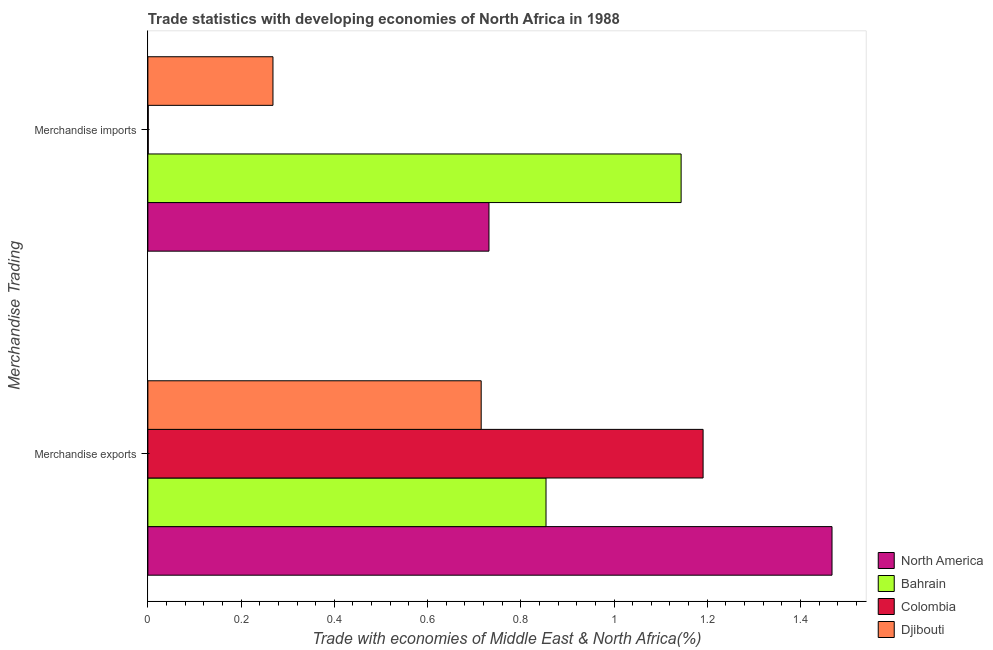How many different coloured bars are there?
Make the answer very short. 4. Are the number of bars on each tick of the Y-axis equal?
Your answer should be very brief. Yes. What is the merchandise exports in North America?
Make the answer very short. 1.47. Across all countries, what is the maximum merchandise exports?
Your answer should be very brief. 1.47. Across all countries, what is the minimum merchandise imports?
Your answer should be very brief. 0. In which country was the merchandise exports minimum?
Offer a terse response. Djibouti. What is the total merchandise exports in the graph?
Ensure brevity in your answer.  4.23. What is the difference between the merchandise exports in North America and that in Bahrain?
Provide a short and direct response. 0.61. What is the difference between the merchandise imports in Djibouti and the merchandise exports in Bahrain?
Your answer should be very brief. -0.59. What is the average merchandise imports per country?
Offer a very short reply. 0.54. What is the difference between the merchandise imports and merchandise exports in Bahrain?
Offer a terse response. 0.29. What is the ratio of the merchandise exports in Djibouti to that in Bahrain?
Your answer should be compact. 0.84. What does the 3rd bar from the top in Merchandise exports represents?
Give a very brief answer. Bahrain. What does the 4th bar from the bottom in Merchandise exports represents?
Offer a terse response. Djibouti. How many countries are there in the graph?
Provide a succinct answer. 4. Does the graph contain any zero values?
Your answer should be very brief. No. Does the graph contain grids?
Your answer should be compact. No. How many legend labels are there?
Your answer should be compact. 4. How are the legend labels stacked?
Provide a succinct answer. Vertical. What is the title of the graph?
Ensure brevity in your answer.  Trade statistics with developing economies of North Africa in 1988. Does "Nicaragua" appear as one of the legend labels in the graph?
Offer a very short reply. No. What is the label or title of the X-axis?
Ensure brevity in your answer.  Trade with economies of Middle East & North Africa(%). What is the label or title of the Y-axis?
Your answer should be very brief. Merchandise Trading. What is the Trade with economies of Middle East & North Africa(%) in North America in Merchandise exports?
Your answer should be very brief. 1.47. What is the Trade with economies of Middle East & North Africa(%) in Bahrain in Merchandise exports?
Your answer should be very brief. 0.85. What is the Trade with economies of Middle East & North Africa(%) in Colombia in Merchandise exports?
Provide a succinct answer. 1.19. What is the Trade with economies of Middle East & North Africa(%) of Djibouti in Merchandise exports?
Keep it short and to the point. 0.72. What is the Trade with economies of Middle East & North Africa(%) in North America in Merchandise imports?
Your answer should be very brief. 0.73. What is the Trade with economies of Middle East & North Africa(%) of Bahrain in Merchandise imports?
Give a very brief answer. 1.14. What is the Trade with economies of Middle East & North Africa(%) of Colombia in Merchandise imports?
Your answer should be very brief. 0. What is the Trade with economies of Middle East & North Africa(%) of Djibouti in Merchandise imports?
Offer a very short reply. 0.27. Across all Merchandise Trading, what is the maximum Trade with economies of Middle East & North Africa(%) of North America?
Ensure brevity in your answer.  1.47. Across all Merchandise Trading, what is the maximum Trade with economies of Middle East & North Africa(%) in Bahrain?
Provide a short and direct response. 1.14. Across all Merchandise Trading, what is the maximum Trade with economies of Middle East & North Africa(%) of Colombia?
Make the answer very short. 1.19. Across all Merchandise Trading, what is the maximum Trade with economies of Middle East & North Africa(%) in Djibouti?
Make the answer very short. 0.72. Across all Merchandise Trading, what is the minimum Trade with economies of Middle East & North Africa(%) of North America?
Your answer should be very brief. 0.73. Across all Merchandise Trading, what is the minimum Trade with economies of Middle East & North Africa(%) of Bahrain?
Give a very brief answer. 0.85. Across all Merchandise Trading, what is the minimum Trade with economies of Middle East & North Africa(%) in Colombia?
Offer a very short reply. 0. Across all Merchandise Trading, what is the minimum Trade with economies of Middle East & North Africa(%) of Djibouti?
Your answer should be very brief. 0.27. What is the total Trade with economies of Middle East & North Africa(%) of North America in the graph?
Offer a very short reply. 2.2. What is the total Trade with economies of Middle East & North Africa(%) of Bahrain in the graph?
Your answer should be very brief. 2. What is the total Trade with economies of Middle East & North Africa(%) of Colombia in the graph?
Ensure brevity in your answer.  1.19. What is the total Trade with economies of Middle East & North Africa(%) in Djibouti in the graph?
Your response must be concise. 0.98. What is the difference between the Trade with economies of Middle East & North Africa(%) of North America in Merchandise exports and that in Merchandise imports?
Your answer should be compact. 0.74. What is the difference between the Trade with economies of Middle East & North Africa(%) in Bahrain in Merchandise exports and that in Merchandise imports?
Offer a terse response. -0.29. What is the difference between the Trade with economies of Middle East & North Africa(%) in Colombia in Merchandise exports and that in Merchandise imports?
Make the answer very short. 1.19. What is the difference between the Trade with economies of Middle East & North Africa(%) in Djibouti in Merchandise exports and that in Merchandise imports?
Your answer should be very brief. 0.45. What is the difference between the Trade with economies of Middle East & North Africa(%) in North America in Merchandise exports and the Trade with economies of Middle East & North Africa(%) in Bahrain in Merchandise imports?
Ensure brevity in your answer.  0.32. What is the difference between the Trade with economies of Middle East & North Africa(%) in North America in Merchandise exports and the Trade with economies of Middle East & North Africa(%) in Colombia in Merchandise imports?
Provide a succinct answer. 1.47. What is the difference between the Trade with economies of Middle East & North Africa(%) of North America in Merchandise exports and the Trade with economies of Middle East & North Africa(%) of Djibouti in Merchandise imports?
Provide a succinct answer. 1.2. What is the difference between the Trade with economies of Middle East & North Africa(%) in Bahrain in Merchandise exports and the Trade with economies of Middle East & North Africa(%) in Colombia in Merchandise imports?
Your answer should be compact. 0.85. What is the difference between the Trade with economies of Middle East & North Africa(%) in Bahrain in Merchandise exports and the Trade with economies of Middle East & North Africa(%) in Djibouti in Merchandise imports?
Your answer should be very brief. 0.59. What is the difference between the Trade with economies of Middle East & North Africa(%) in Colombia in Merchandise exports and the Trade with economies of Middle East & North Africa(%) in Djibouti in Merchandise imports?
Give a very brief answer. 0.92. What is the average Trade with economies of Middle East & North Africa(%) in North America per Merchandise Trading?
Provide a succinct answer. 1.1. What is the average Trade with economies of Middle East & North Africa(%) in Bahrain per Merchandise Trading?
Your answer should be very brief. 1. What is the average Trade with economies of Middle East & North Africa(%) of Colombia per Merchandise Trading?
Offer a terse response. 0.6. What is the average Trade with economies of Middle East & North Africa(%) in Djibouti per Merchandise Trading?
Make the answer very short. 0.49. What is the difference between the Trade with economies of Middle East & North Africa(%) in North America and Trade with economies of Middle East & North Africa(%) in Bahrain in Merchandise exports?
Make the answer very short. 0.61. What is the difference between the Trade with economies of Middle East & North Africa(%) of North America and Trade with economies of Middle East & North Africa(%) of Colombia in Merchandise exports?
Make the answer very short. 0.28. What is the difference between the Trade with economies of Middle East & North Africa(%) in North America and Trade with economies of Middle East & North Africa(%) in Djibouti in Merchandise exports?
Your answer should be compact. 0.75. What is the difference between the Trade with economies of Middle East & North Africa(%) of Bahrain and Trade with economies of Middle East & North Africa(%) of Colombia in Merchandise exports?
Offer a terse response. -0.34. What is the difference between the Trade with economies of Middle East & North Africa(%) of Bahrain and Trade with economies of Middle East & North Africa(%) of Djibouti in Merchandise exports?
Ensure brevity in your answer.  0.14. What is the difference between the Trade with economies of Middle East & North Africa(%) of Colombia and Trade with economies of Middle East & North Africa(%) of Djibouti in Merchandise exports?
Provide a succinct answer. 0.48. What is the difference between the Trade with economies of Middle East & North Africa(%) in North America and Trade with economies of Middle East & North Africa(%) in Bahrain in Merchandise imports?
Offer a terse response. -0.41. What is the difference between the Trade with economies of Middle East & North Africa(%) of North America and Trade with economies of Middle East & North Africa(%) of Colombia in Merchandise imports?
Offer a very short reply. 0.73. What is the difference between the Trade with economies of Middle East & North Africa(%) of North America and Trade with economies of Middle East & North Africa(%) of Djibouti in Merchandise imports?
Your answer should be very brief. 0.46. What is the difference between the Trade with economies of Middle East & North Africa(%) of Bahrain and Trade with economies of Middle East & North Africa(%) of Colombia in Merchandise imports?
Offer a terse response. 1.14. What is the difference between the Trade with economies of Middle East & North Africa(%) in Bahrain and Trade with economies of Middle East & North Africa(%) in Djibouti in Merchandise imports?
Your answer should be very brief. 0.88. What is the difference between the Trade with economies of Middle East & North Africa(%) of Colombia and Trade with economies of Middle East & North Africa(%) of Djibouti in Merchandise imports?
Offer a very short reply. -0.27. What is the ratio of the Trade with economies of Middle East & North Africa(%) of North America in Merchandise exports to that in Merchandise imports?
Give a very brief answer. 2.01. What is the ratio of the Trade with economies of Middle East & North Africa(%) of Bahrain in Merchandise exports to that in Merchandise imports?
Ensure brevity in your answer.  0.75. What is the ratio of the Trade with economies of Middle East & North Africa(%) of Colombia in Merchandise exports to that in Merchandise imports?
Ensure brevity in your answer.  1508.43. What is the ratio of the Trade with economies of Middle East & North Africa(%) in Djibouti in Merchandise exports to that in Merchandise imports?
Provide a succinct answer. 2.66. What is the difference between the highest and the second highest Trade with economies of Middle East & North Africa(%) in North America?
Provide a succinct answer. 0.74. What is the difference between the highest and the second highest Trade with economies of Middle East & North Africa(%) in Bahrain?
Make the answer very short. 0.29. What is the difference between the highest and the second highest Trade with economies of Middle East & North Africa(%) of Colombia?
Make the answer very short. 1.19. What is the difference between the highest and the second highest Trade with economies of Middle East & North Africa(%) in Djibouti?
Offer a very short reply. 0.45. What is the difference between the highest and the lowest Trade with economies of Middle East & North Africa(%) in North America?
Provide a short and direct response. 0.74. What is the difference between the highest and the lowest Trade with economies of Middle East & North Africa(%) in Bahrain?
Your answer should be very brief. 0.29. What is the difference between the highest and the lowest Trade with economies of Middle East & North Africa(%) of Colombia?
Provide a short and direct response. 1.19. What is the difference between the highest and the lowest Trade with economies of Middle East & North Africa(%) of Djibouti?
Keep it short and to the point. 0.45. 